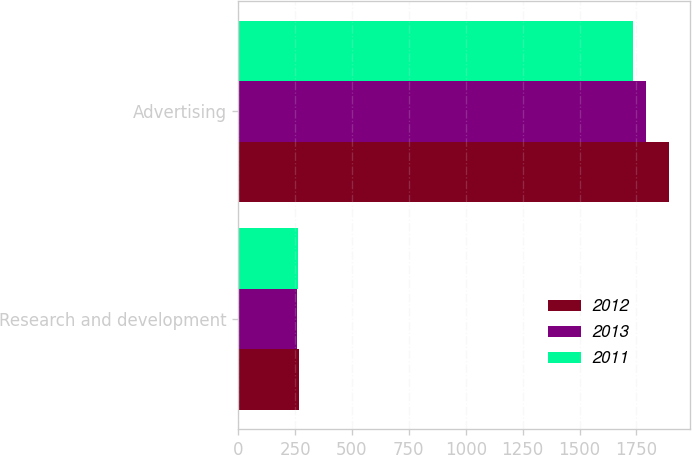Convert chart. <chart><loc_0><loc_0><loc_500><loc_500><stacked_bar_chart><ecel><fcel>Research and development<fcel>Advertising<nl><fcel>2012<fcel>267<fcel>1891<nl><fcel>2013<fcel>259<fcel>1792<nl><fcel>2011<fcel>262<fcel>1734<nl></chart> 